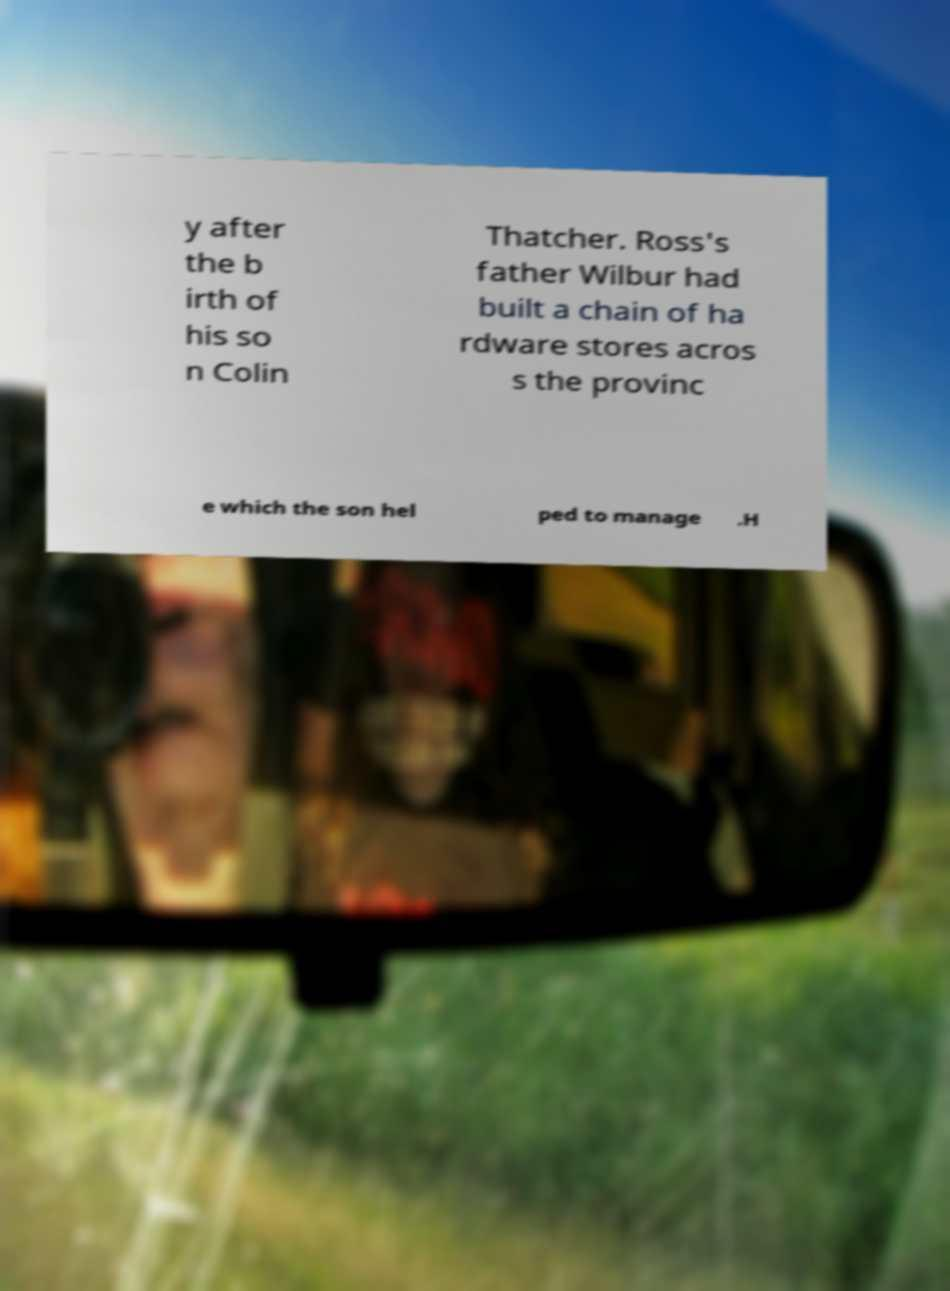For documentation purposes, I need the text within this image transcribed. Could you provide that? y after the b irth of his so n Colin Thatcher. Ross's father Wilbur had built a chain of ha rdware stores acros s the provinc e which the son hel ped to manage .H 